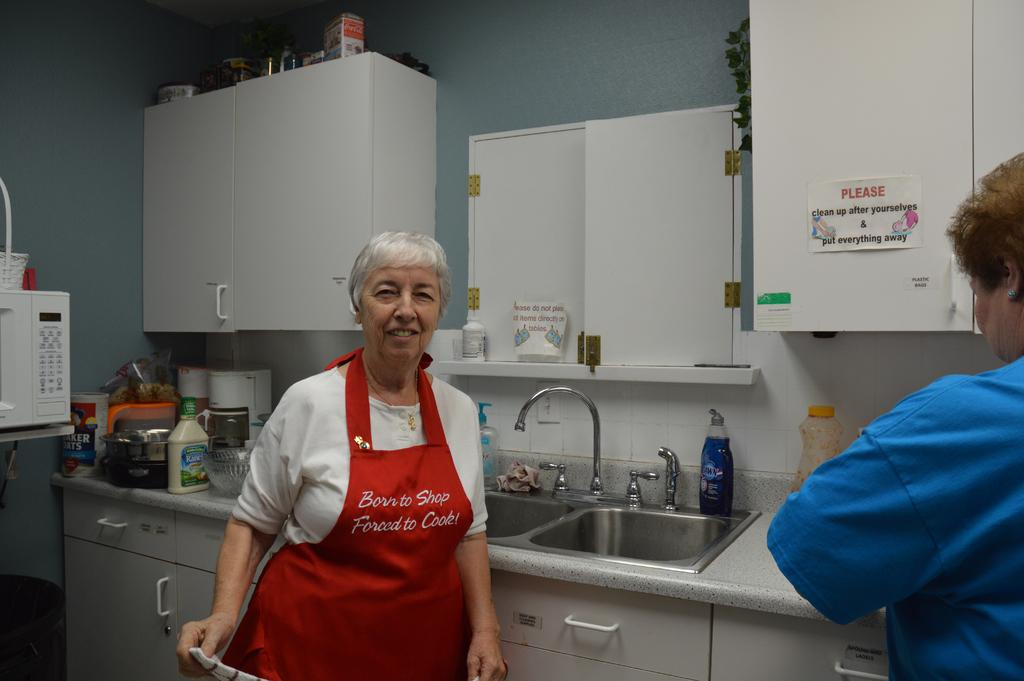Provide a one-sentence caption for the provided image. An older woman with Born to Shop Forced to Cook on her red apron stands by a sink. 